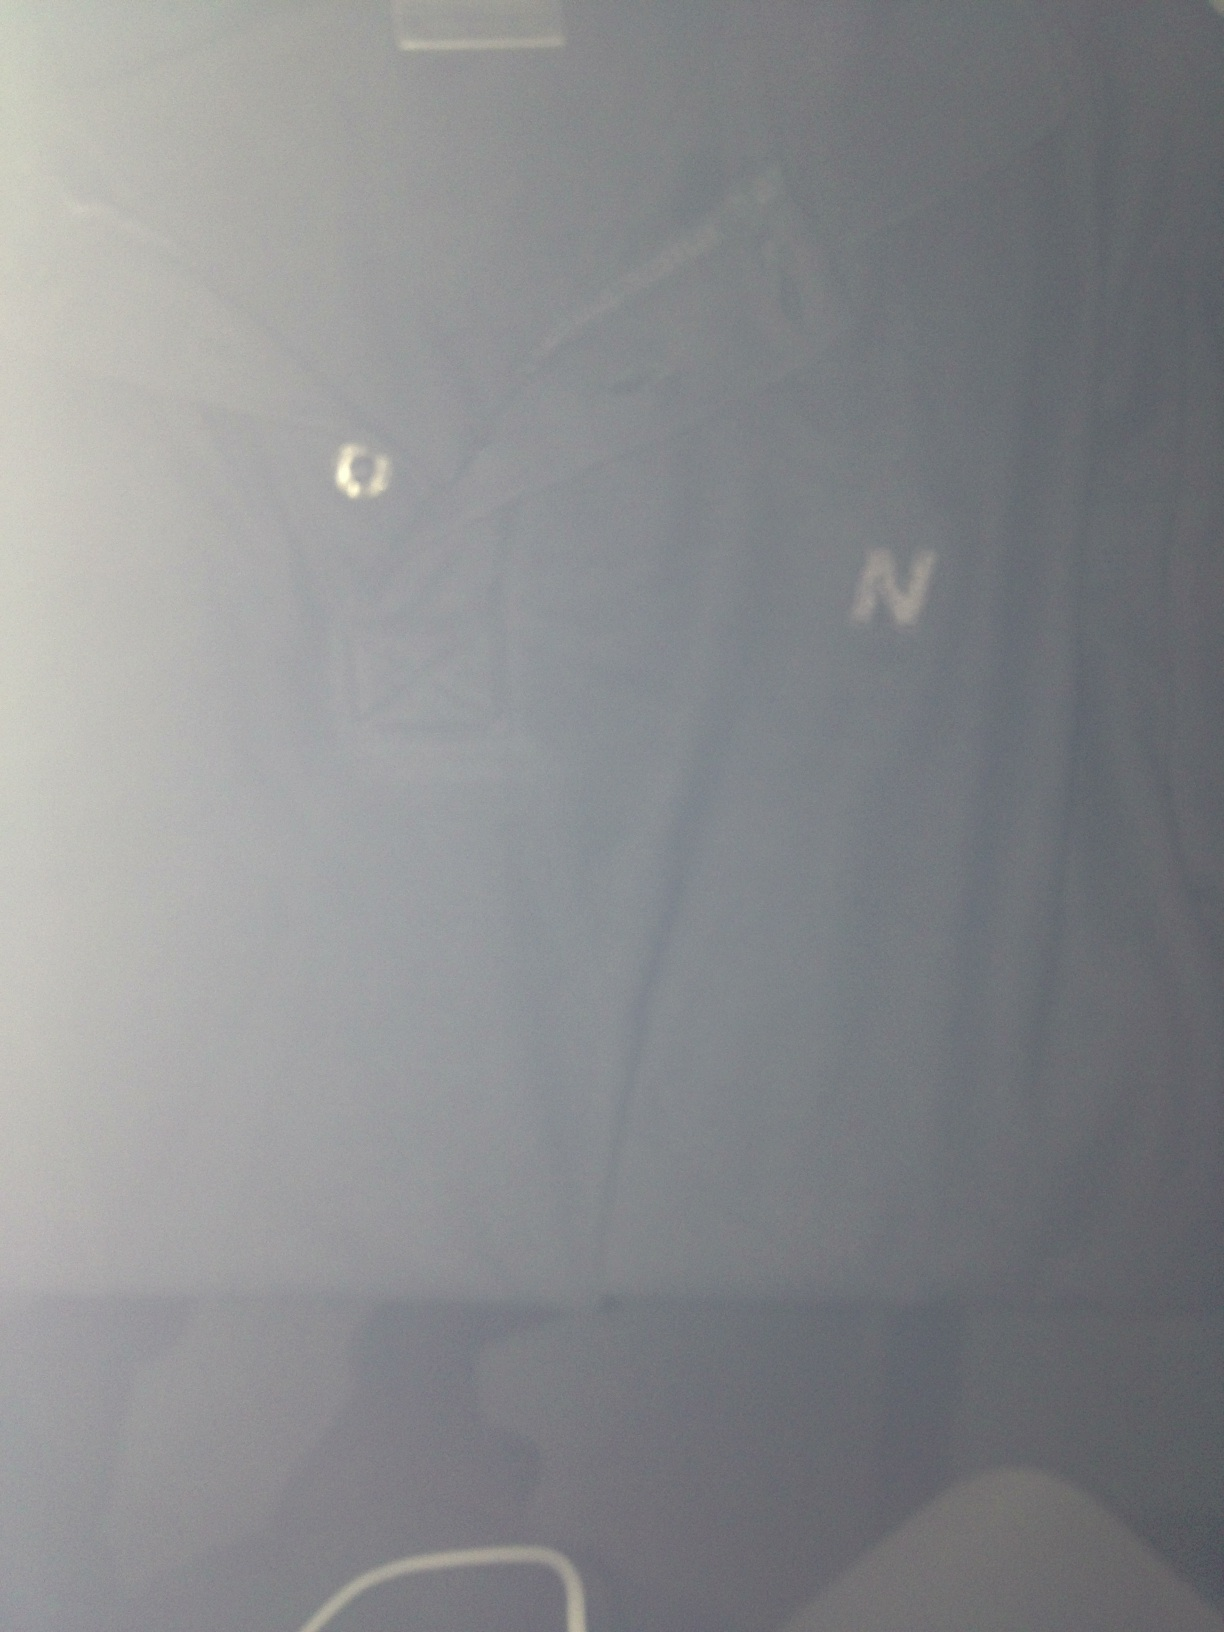Discuss the possible historical significance of having a single emblem on clothing. The presence of a single emblem on clothing can often be significant, representing various elements such as heritage, identity, or affiliations. Historically, emblems have been used to denote membership in certain groups or organizations, to indicate status, or to convey specific values. In medieval times, emblems and crests were used on garments to identify knights and noblemen. In modern fashion, a single emblem can serve as a logo for a brand, embody the essence of the wearer's style, or pay homage to cultural symbols. The 'N' on this tee shirt might represent a brand, a school, or even a personal monogram, each telling a different story. 